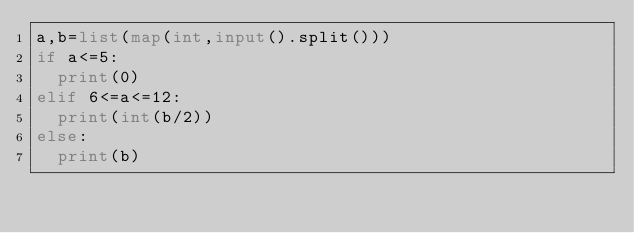Convert code to text. <code><loc_0><loc_0><loc_500><loc_500><_Python_>a,b=list(map(int,input().split()))
if a<=5:
  print(0)
elif 6<=a<=12:
  print(int(b/2))
else:
  print(b)</code> 